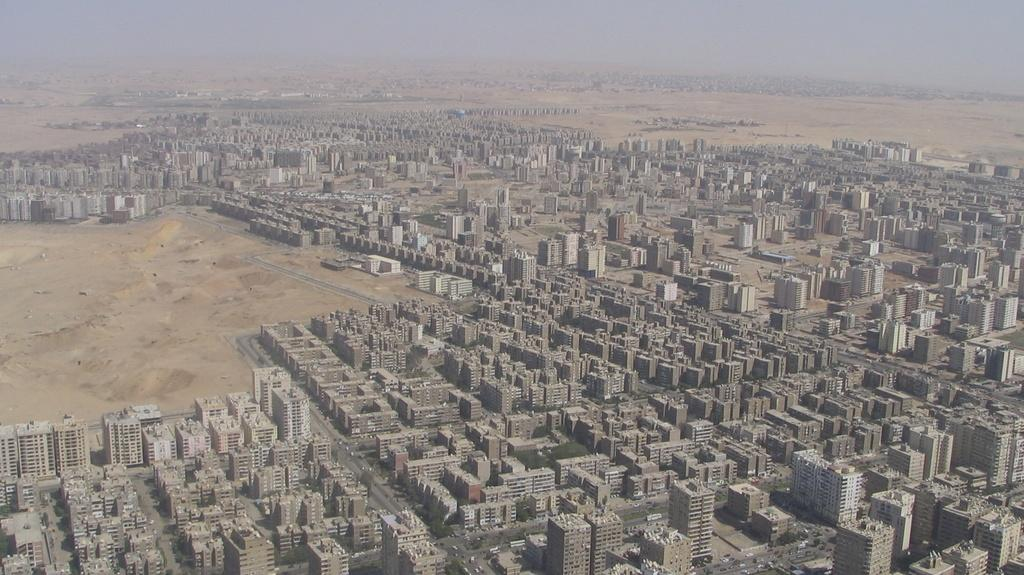What type of view is shown in the image? The image is a top view. What type of structures can be seen in the image? There are buildings visible in the image. What is the condition of the sky in the image? The sky is cloudy in the image. What type of toy can be seen made of metal in the image? There is no toy visible in the image, and there is no mention of a metal object. 